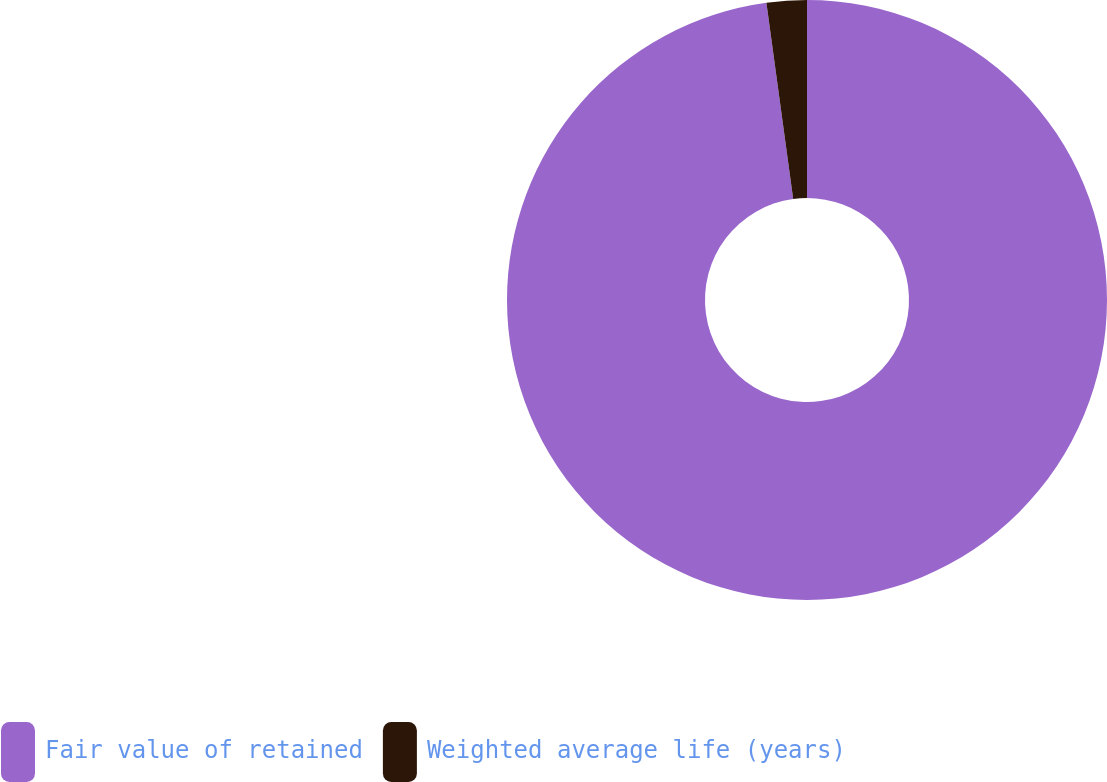Convert chart. <chart><loc_0><loc_0><loc_500><loc_500><pie_chart><fcel>Fair value of retained<fcel>Weighted average life (years)<nl><fcel>97.84%<fcel>2.16%<nl></chart> 